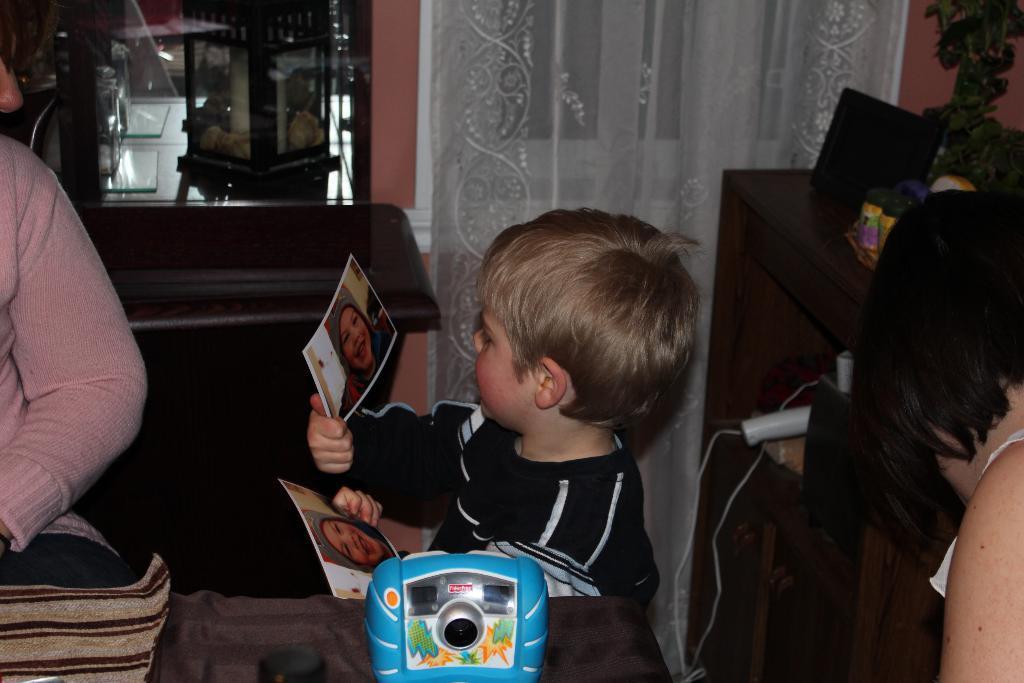In one or two sentences, can you explain what this image depicts? In this image there is a boy standing beside the table and holding photos in hand, beside them there is another person standing and also there is a table with so many things. 